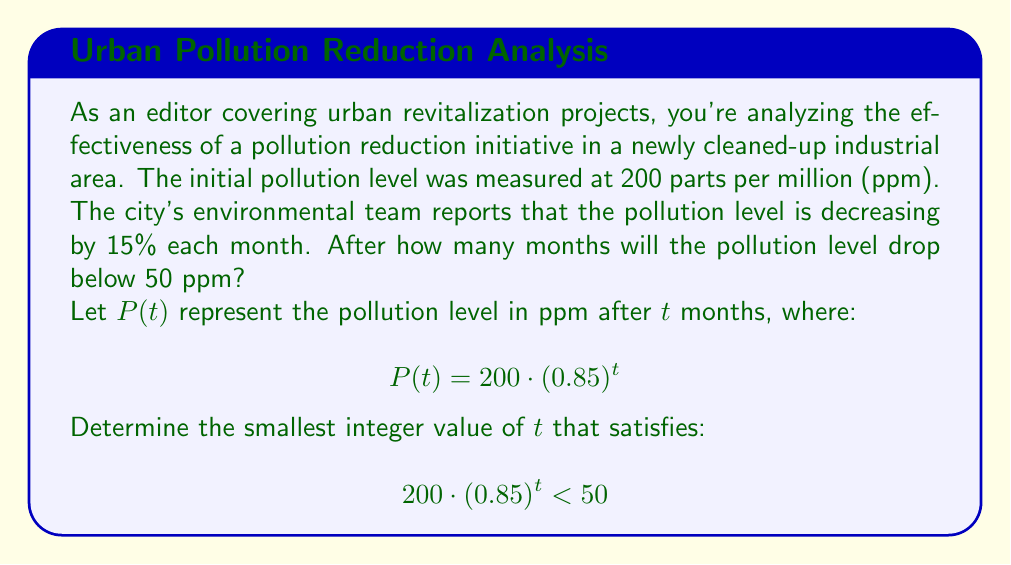Show me your answer to this math problem. To solve this problem, we'll follow these steps:

1) We start with the inequality:
   $$200 \cdot (0.85)^t < 50$$

2) Divide both sides by 200:
   $$(0.85)^t < \frac{50}{200} = 0.25$$

3) Take the natural logarithm of both sides:
   $$\ln((0.85)^t) < \ln(0.25)$$

4) Using the logarithm property $\ln(a^b) = b\ln(a)$:
   $$t \cdot \ln(0.85) < \ln(0.25)$$

5) Divide both sides by $\ln(0.85)$ (note that $\ln(0.85)$ is negative, so the inequality sign flips):
   $$t > \frac{\ln(0.25)}{\ln(0.85)}$$

6) Calculate the right-hand side:
   $$t > \frac{\ln(0.25)}{\ln(0.85)} \approx 8.9657$$

7) Since we need the smallest integer value of $t$, we round up to the next whole number.
Answer: The pollution level will drop below 50 ppm after 9 months. 